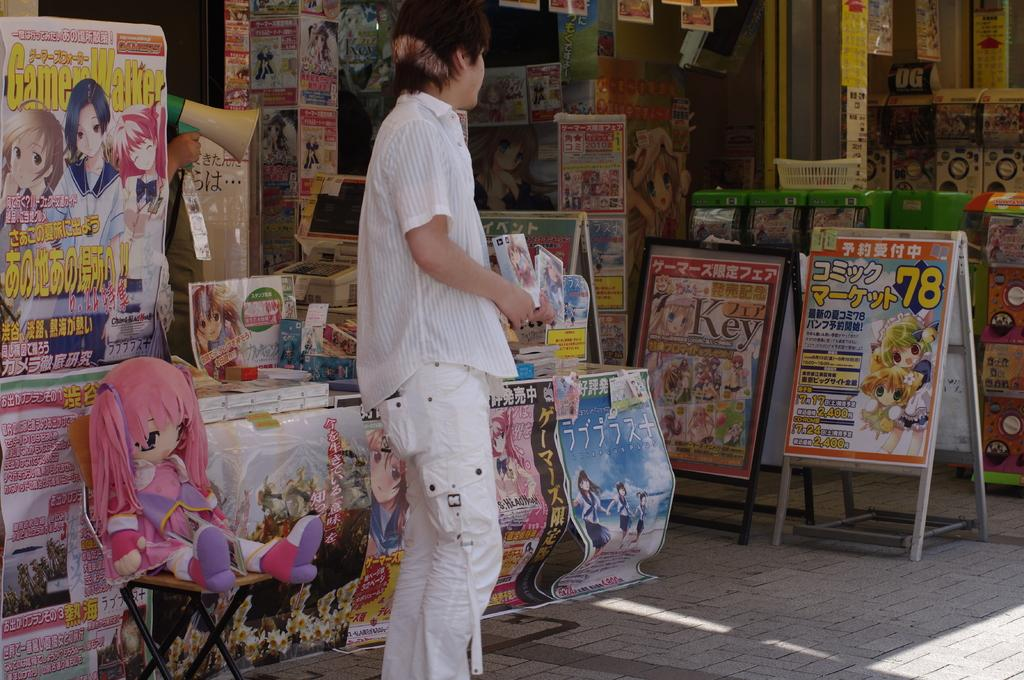<image>
Relay a brief, clear account of the picture shown. A store that sells goods based on animations and has foreign writing. 